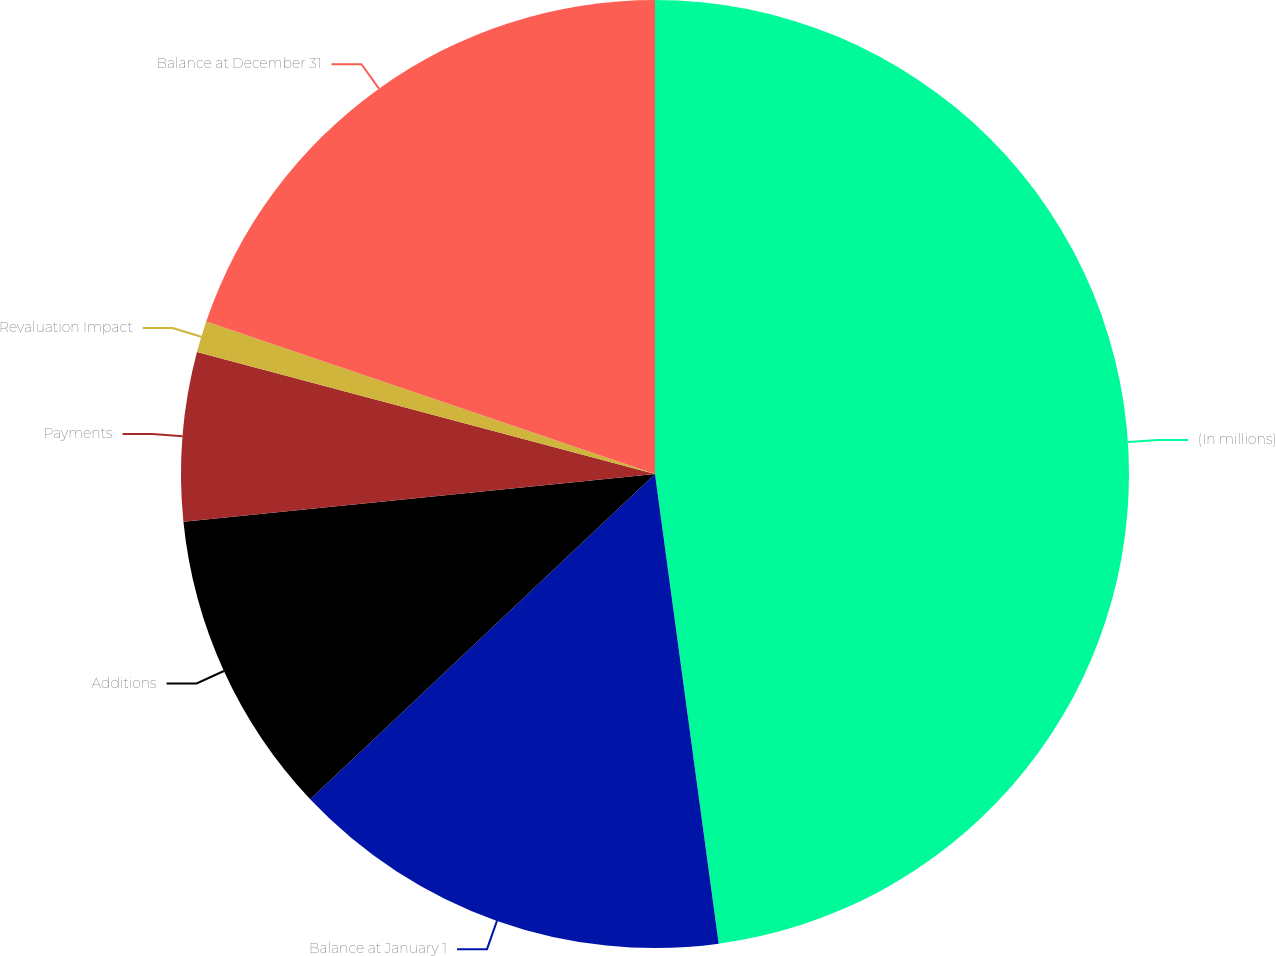Convert chart to OTSL. <chart><loc_0><loc_0><loc_500><loc_500><pie_chart><fcel>(In millions)<fcel>Balance at January 1<fcel>Additions<fcel>Payments<fcel>Revaluation Impact<fcel>Balance at December 31<nl><fcel>47.86%<fcel>15.11%<fcel>10.43%<fcel>5.75%<fcel>1.07%<fcel>19.79%<nl></chart> 